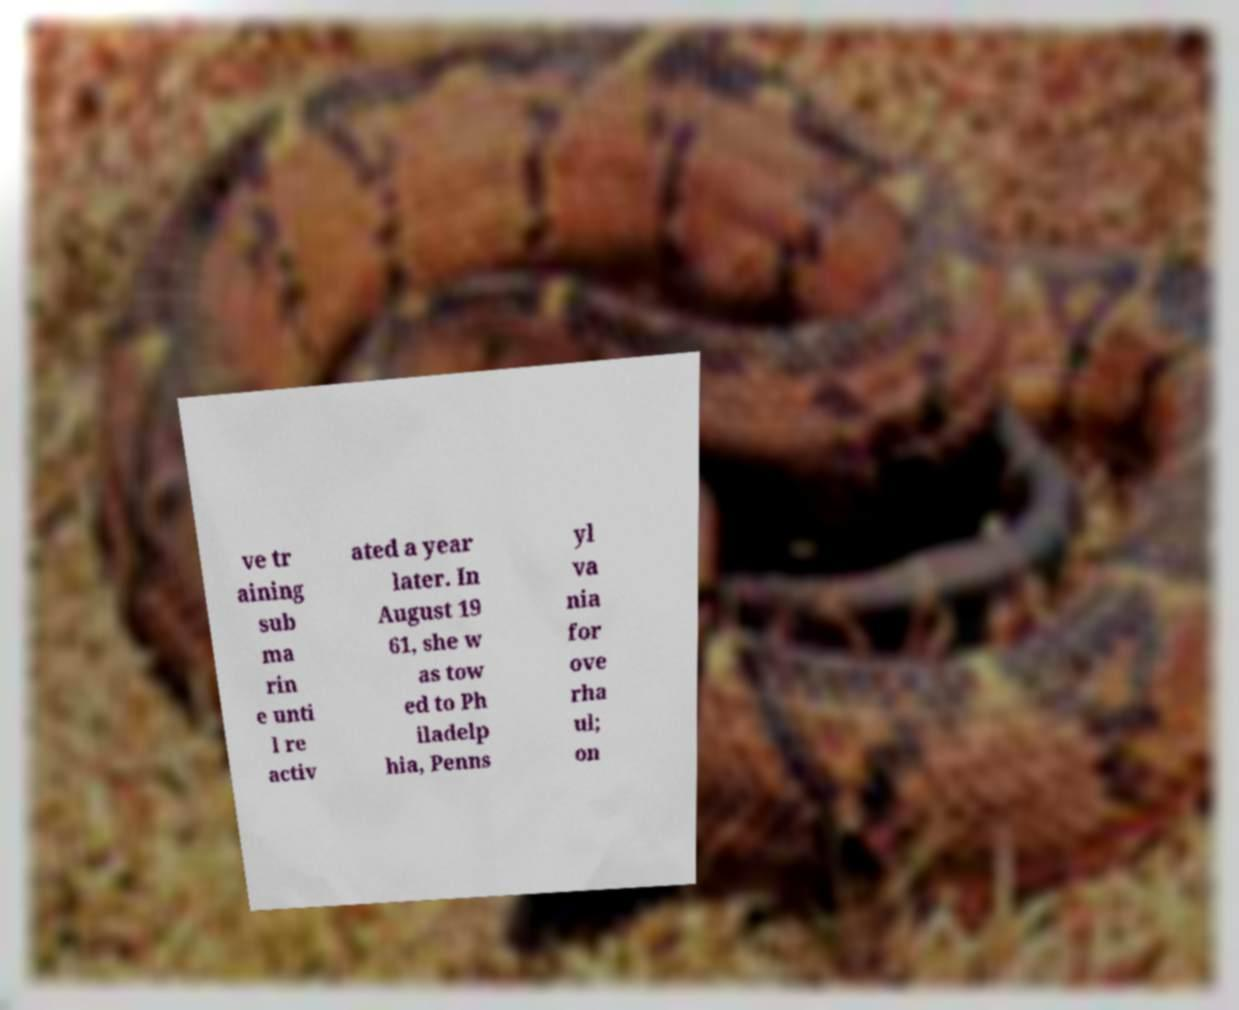For documentation purposes, I need the text within this image transcribed. Could you provide that? ve tr aining sub ma rin e unti l re activ ated a year later. In August 19 61, she w as tow ed to Ph iladelp hia, Penns yl va nia for ove rha ul; on 